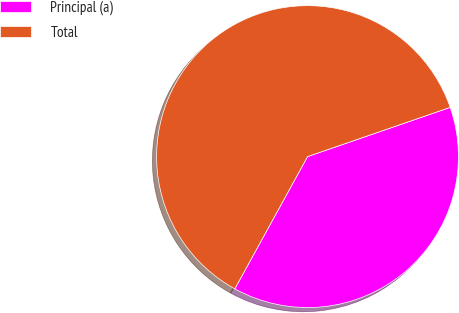Convert chart. <chart><loc_0><loc_0><loc_500><loc_500><pie_chart><fcel>Principal (a)<fcel>Total<nl><fcel>38.29%<fcel>61.71%<nl></chart> 